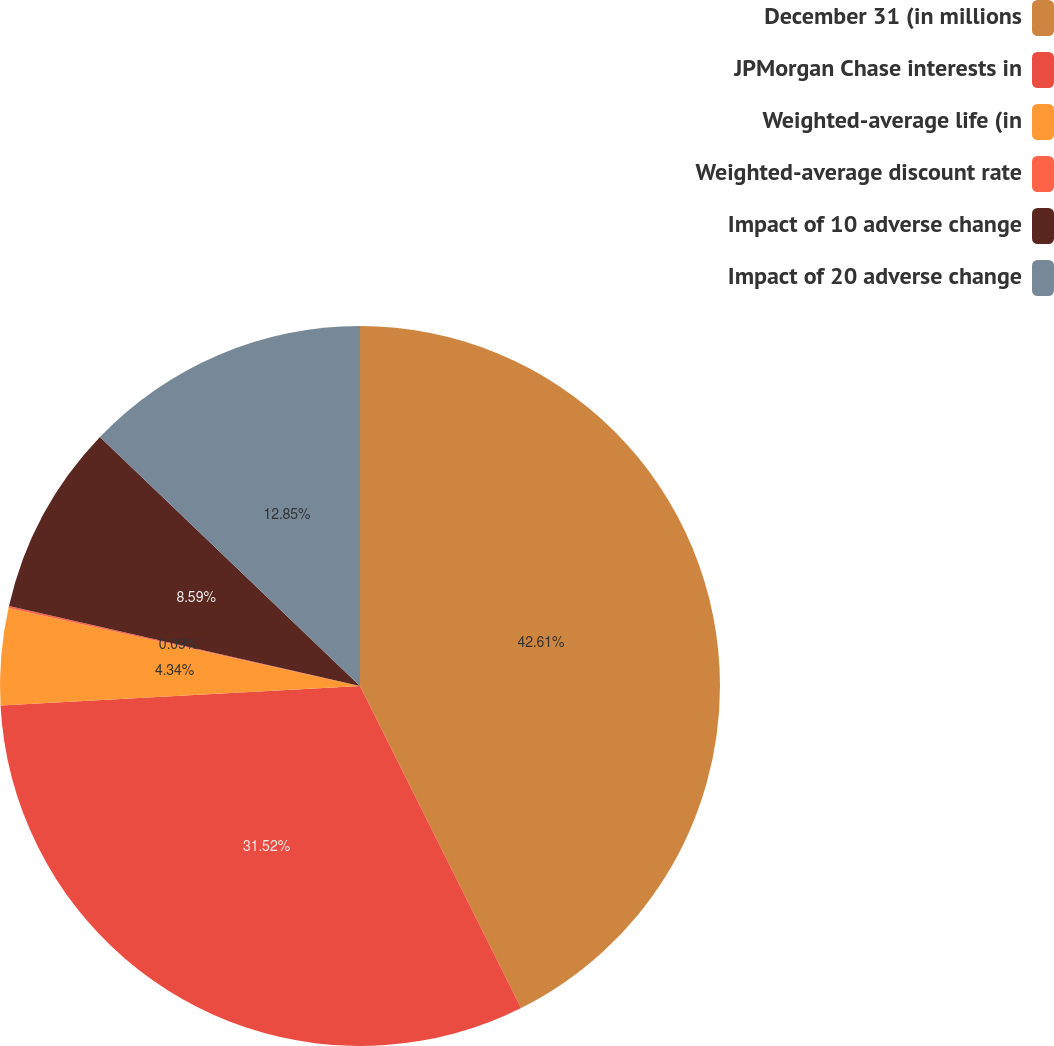Convert chart to OTSL. <chart><loc_0><loc_0><loc_500><loc_500><pie_chart><fcel>December 31 (in millions<fcel>JPMorgan Chase interests in<fcel>Weighted-average life (in<fcel>Weighted-average discount rate<fcel>Impact of 10 adverse change<fcel>Impact of 20 adverse change<nl><fcel>42.62%<fcel>31.52%<fcel>4.34%<fcel>0.09%<fcel>8.59%<fcel>12.85%<nl></chart> 